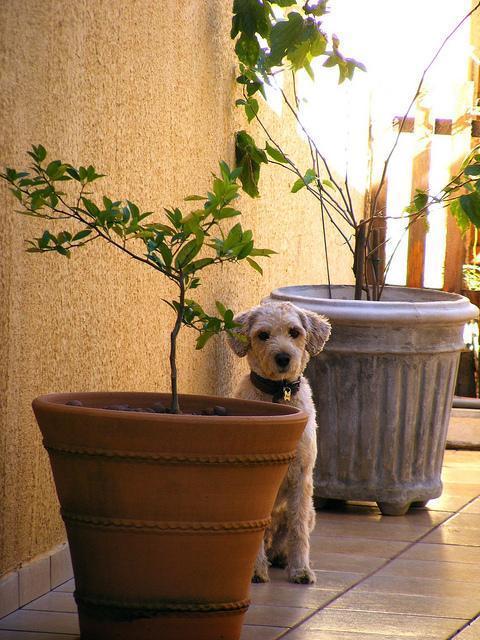How many potted plants can be seen?
Give a very brief answer. 2. 